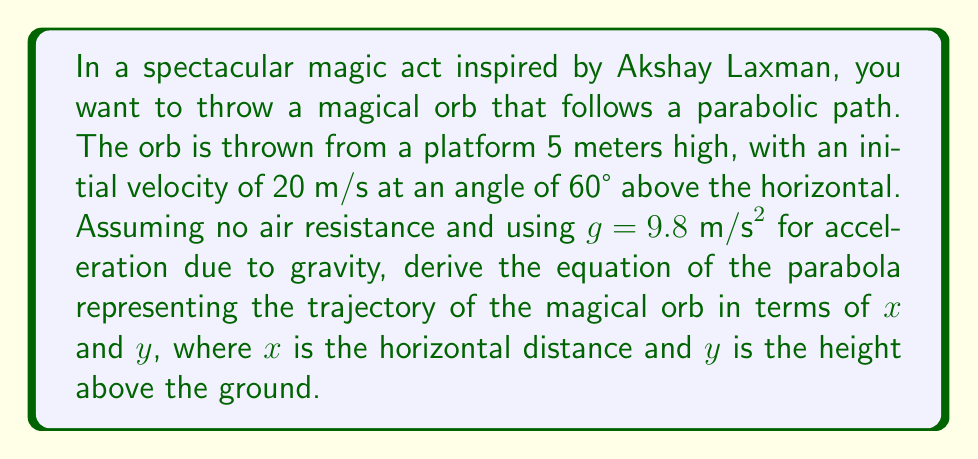Show me your answer to this math problem. Let's approach this step-by-step:

1) First, we need to break down the initial velocity into its horizontal and vertical components:
   $v_x = 20 \cos(60°) = 10 \text{ m/s}$
   $v_y = 20 \sin(60°) = 17.32 \text{ m/s}$

2) The horizontal motion is uniform, so $x = v_x t$, where $t$ is time.
   $t = \frac{x}{v_x} = \frac{x}{10}$

3) For the vertical motion, we use the equation:
   $y = y_0 + v_y t - \frac{1}{2}gt^2$
   where $y_0 = 5$ (initial height)

4) Substituting $t = \frac{x}{10}$ into the vertical motion equation:
   $y = 5 + 17.32(\frac{x}{10}) - \frac{1}{2}(9.8)(\frac{x}{10})^2$

5) Simplifying:
   $y = 5 + 1.732x - 0.049x^2$

6) Rearranging to standard form of a parabola $y = ax^2 + bx + c$:
   $y = -0.049x^2 + 1.732x + 5$

This is the equation of the parabola representing the trajectory of the magical orb.
Answer: $y = -0.049x^2 + 1.732x + 5$ 